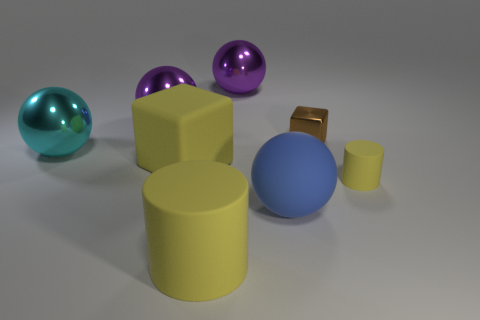What size is the metal block?
Give a very brief answer. Small. Is the brown metallic block the same size as the cyan object?
Ensure brevity in your answer.  No. How many things are either rubber things that are in front of the small matte cylinder or yellow matte things on the left side of the brown metallic cube?
Your answer should be compact. 3. There is a blue ball on the right side of the matte cylinder that is to the left of the brown object; how many yellow things are in front of it?
Keep it short and to the point. 1. What size is the rubber cylinder on the right side of the big blue ball?
Ensure brevity in your answer.  Small. What number of purple shiny things are the same size as the matte ball?
Ensure brevity in your answer.  2. Does the yellow matte block have the same size as the yellow rubber cylinder to the right of the large yellow matte cylinder?
Provide a short and direct response. No. What number of things are tiny cyan blocks or metallic objects?
Ensure brevity in your answer.  4. How many other tiny things have the same color as the tiny shiny thing?
Your answer should be compact. 0. The cyan metal object that is the same size as the rubber block is what shape?
Your response must be concise. Sphere. 